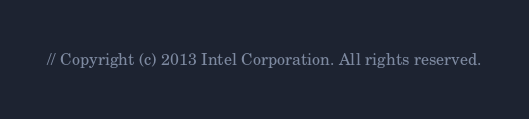<code> <loc_0><loc_0><loc_500><loc_500><_C++_>// Copyright (c) 2013 Intel Corporation. All rights reserved.</code> 